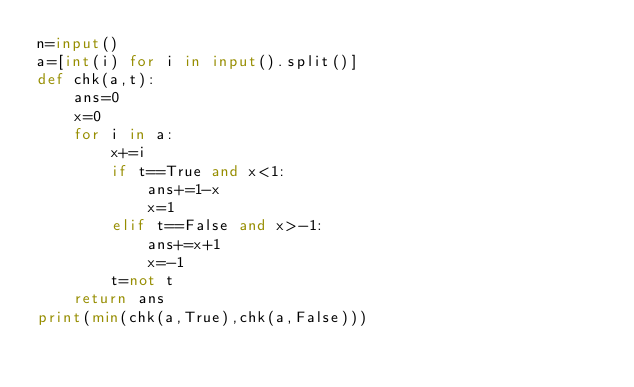Convert code to text. <code><loc_0><loc_0><loc_500><loc_500><_Python_>n=input()
a=[int(i) for i in input().split()]
def chk(a,t):
    ans=0
    x=0
    for i in a:
        x+=i
        if t==True and x<1:
            ans+=1-x
            x=1
        elif t==False and x>-1:
            ans+=x+1
            x=-1
        t=not t
    return ans
print(min(chk(a,True),chk(a,False)))</code> 